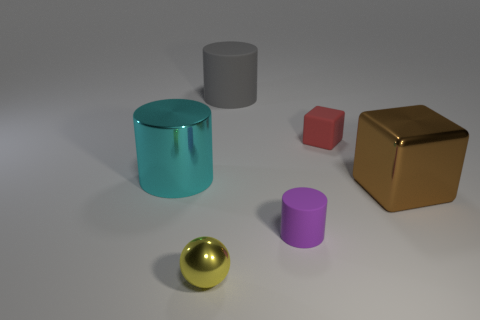Add 3 tiny brown things. How many objects exist? 9 Subtract all balls. How many objects are left? 5 Add 2 cylinders. How many cylinders exist? 5 Subtract 1 cyan cylinders. How many objects are left? 5 Subtract all tiny red metal spheres. Subtract all small matte cubes. How many objects are left? 5 Add 4 yellow spheres. How many yellow spheres are left? 5 